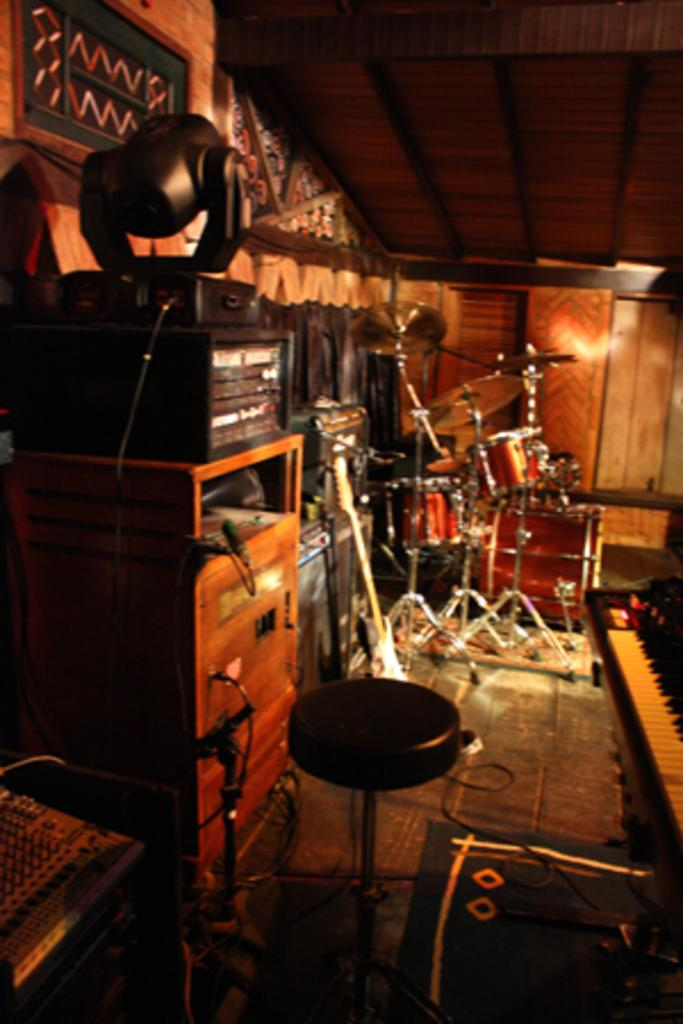What objects in the image are related to music? There are musical instruments in the image. What device is present for amplifying sound? There is a sound system in the image. What type of lighting is visible in the image? There are lights in the image. What theory is being discussed in the image? There is no indication of a theory being discussed in the image; it primarily features musical instruments, a sound system, and lights. Can you see any books in the image? There is no mention of books in the image; it focuses on musical instruments, a sound system, and lights. 